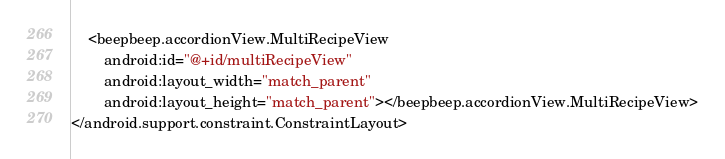<code> <loc_0><loc_0><loc_500><loc_500><_XML_>    <beepbeep.accordionView.MultiRecipeView
        android:id="@+id/multiRecipeView"
        android:layout_width="match_parent"
        android:layout_height="match_parent"></beepbeep.accordionView.MultiRecipeView>
</android.support.constraint.ConstraintLayout></code> 